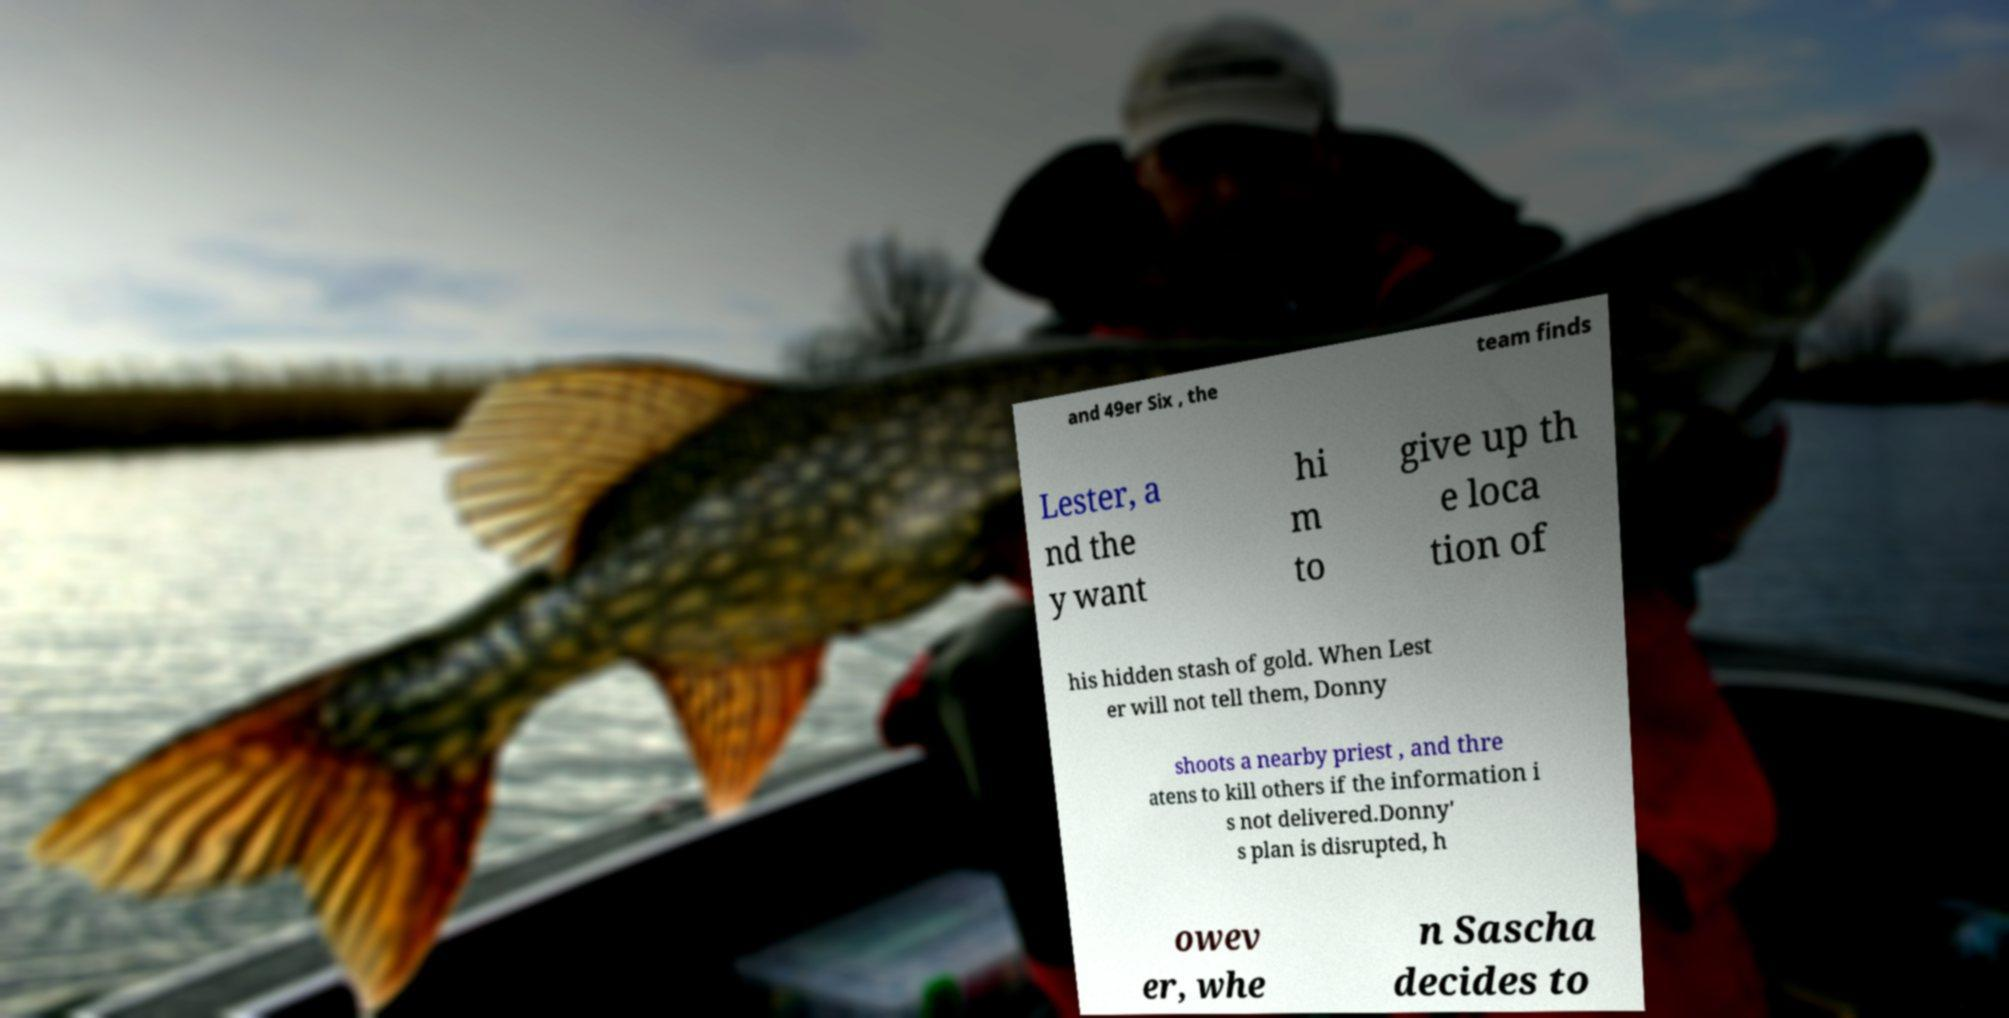Could you extract and type out the text from this image? and 49er Six , the team finds Lester, a nd the y want hi m to give up th e loca tion of his hidden stash of gold. When Lest er will not tell them, Donny shoots a nearby priest , and thre atens to kill others if the information i s not delivered.Donny' s plan is disrupted, h owev er, whe n Sascha decides to 